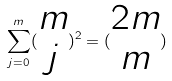<formula> <loc_0><loc_0><loc_500><loc_500>\sum _ { j = 0 } ^ { m } ( \begin{matrix} m \\ j \end{matrix} ) ^ { 2 } = ( \begin{matrix} 2 m \\ m \end{matrix} )</formula> 